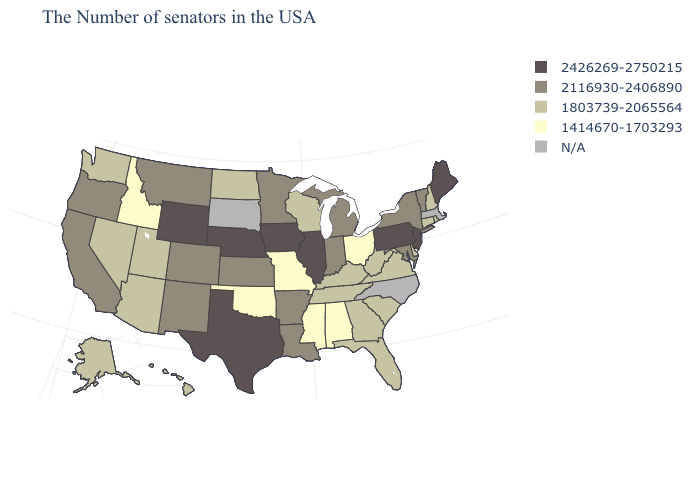Does Rhode Island have the lowest value in the Northeast?
Be succinct. Yes. Name the states that have a value in the range 2426269-2750215?
Keep it brief. Maine, New Jersey, Pennsylvania, Illinois, Iowa, Nebraska, Texas, Wyoming. Name the states that have a value in the range N/A?
Quick response, please. Massachusetts, North Carolina, South Dakota. Name the states that have a value in the range N/A?
Answer briefly. Massachusetts, North Carolina, South Dakota. How many symbols are there in the legend?
Short answer required. 5. What is the value of Iowa?
Write a very short answer. 2426269-2750215. Among the states that border Nebraska , does Colorado have the highest value?
Keep it brief. No. Name the states that have a value in the range 2426269-2750215?
Quick response, please. Maine, New Jersey, Pennsylvania, Illinois, Iowa, Nebraska, Texas, Wyoming. What is the highest value in states that border Pennsylvania?
Write a very short answer. 2426269-2750215. Name the states that have a value in the range N/A?
Be succinct. Massachusetts, North Carolina, South Dakota. Does Idaho have the lowest value in the West?
Keep it brief. Yes. Which states have the highest value in the USA?
Write a very short answer. Maine, New Jersey, Pennsylvania, Illinois, Iowa, Nebraska, Texas, Wyoming. Does North Dakota have the highest value in the MidWest?
Answer briefly. No. 